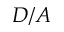Convert formula to latex. <formula><loc_0><loc_0><loc_500><loc_500>D / A</formula> 